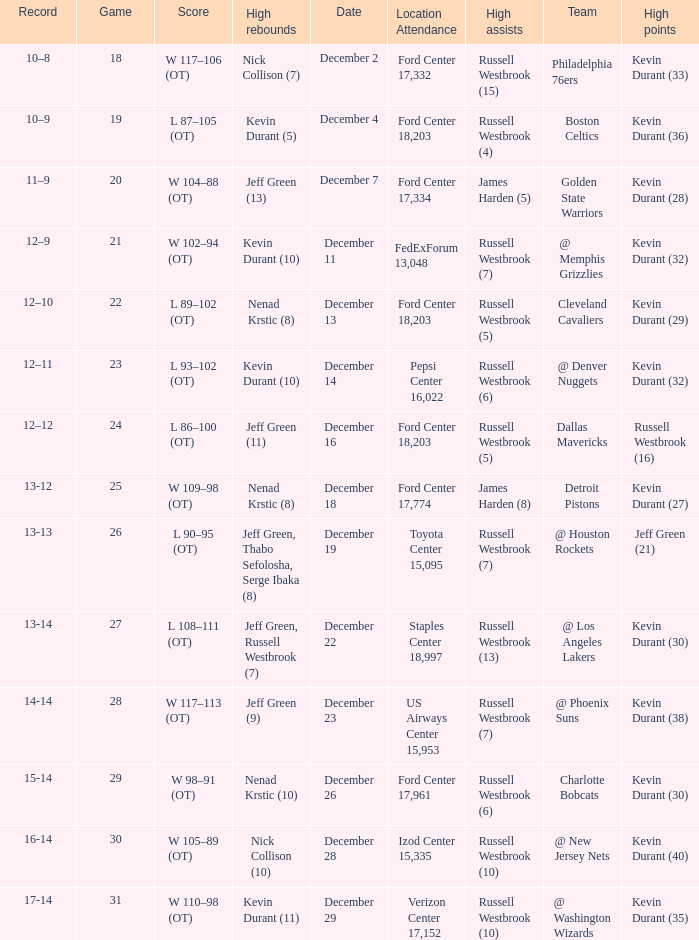Who has high points when toyota center 15,095 is location attendance? Jeff Green (21). 